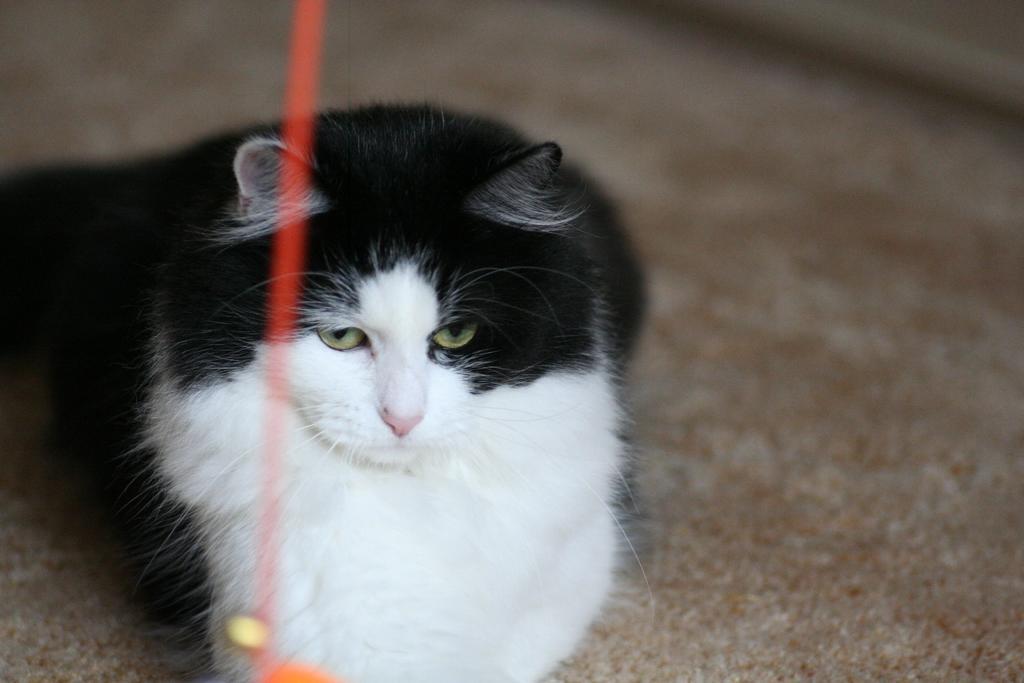In one or two sentences, can you explain what this image depicts? In this picture I can see a red color thing in front, which is blurred and behind it I can see a cat, which is of black and white in color and I see the brown color surface which is a bit blurred. 